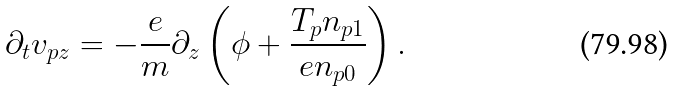Convert formula to latex. <formula><loc_0><loc_0><loc_500><loc_500>\partial _ { t } v _ { p z } = - \frac { e } { m } \partial _ { z } \left ( \phi + \frac { T _ { p } n _ { p 1 } } { e n _ { p 0 } } \right ) .</formula> 